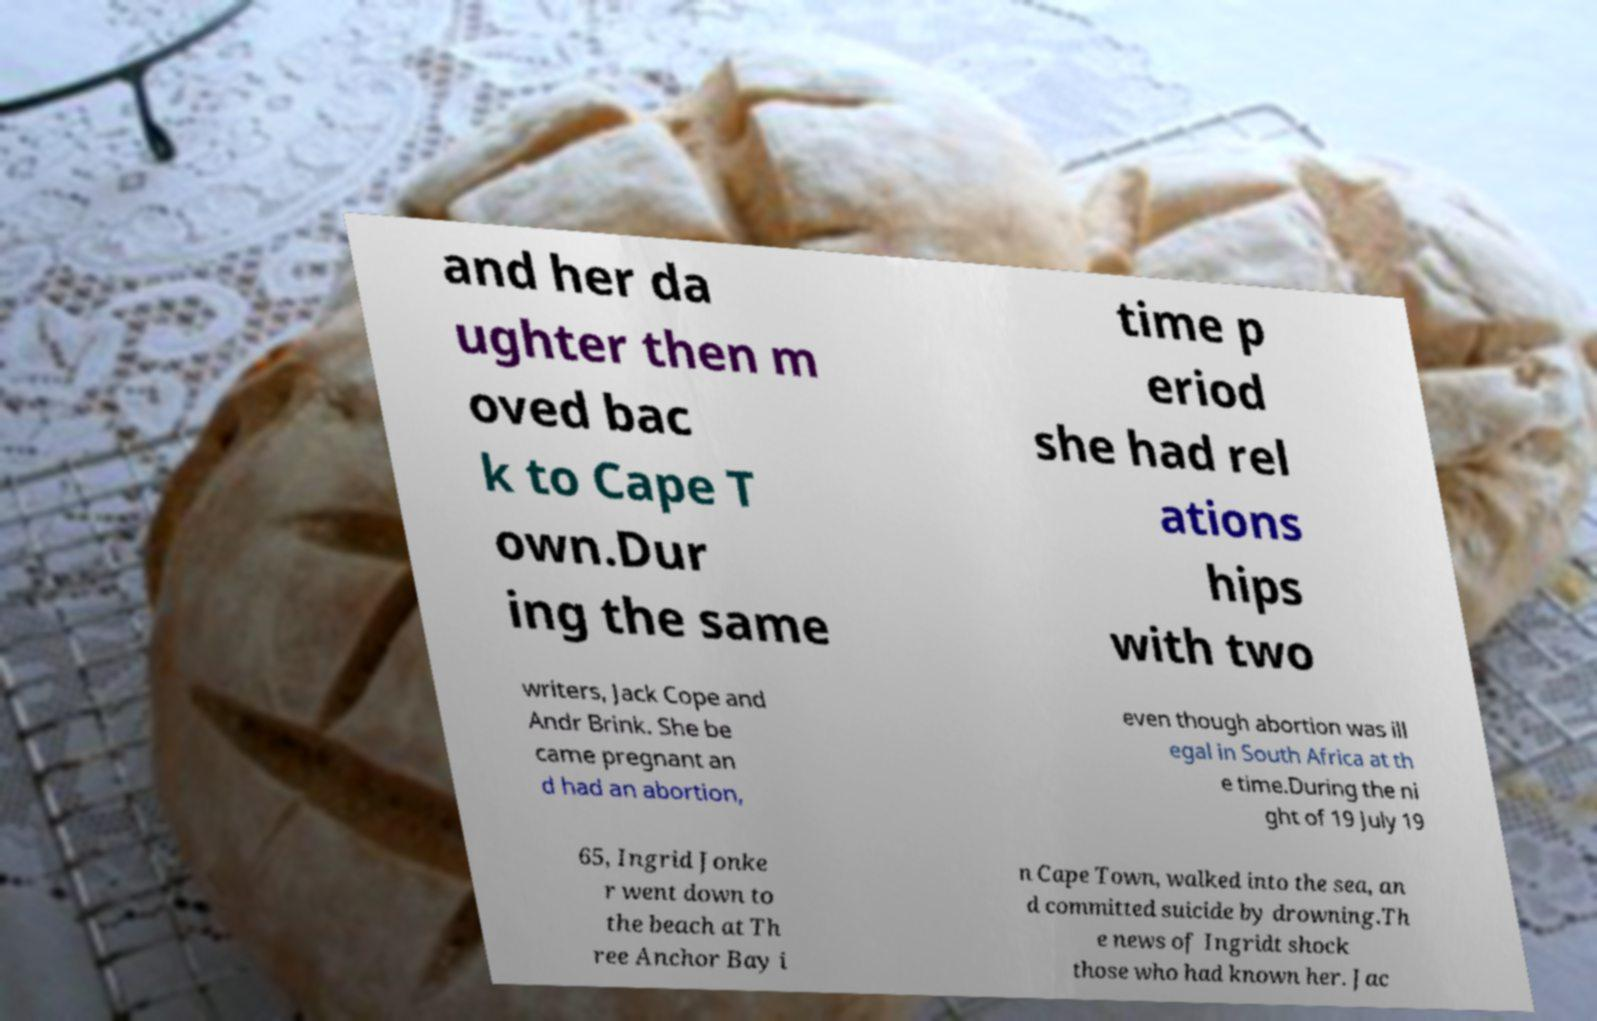Could you assist in decoding the text presented in this image and type it out clearly? and her da ughter then m oved bac k to Cape T own.Dur ing the same time p eriod she had rel ations hips with two writers, Jack Cope and Andr Brink. She be came pregnant an d had an abortion, even though abortion was ill egal in South Africa at th e time.During the ni ght of 19 July 19 65, Ingrid Jonke r went down to the beach at Th ree Anchor Bay i n Cape Town, walked into the sea, an d committed suicide by drowning.Th e news of Ingridt shock those who had known her. Jac 